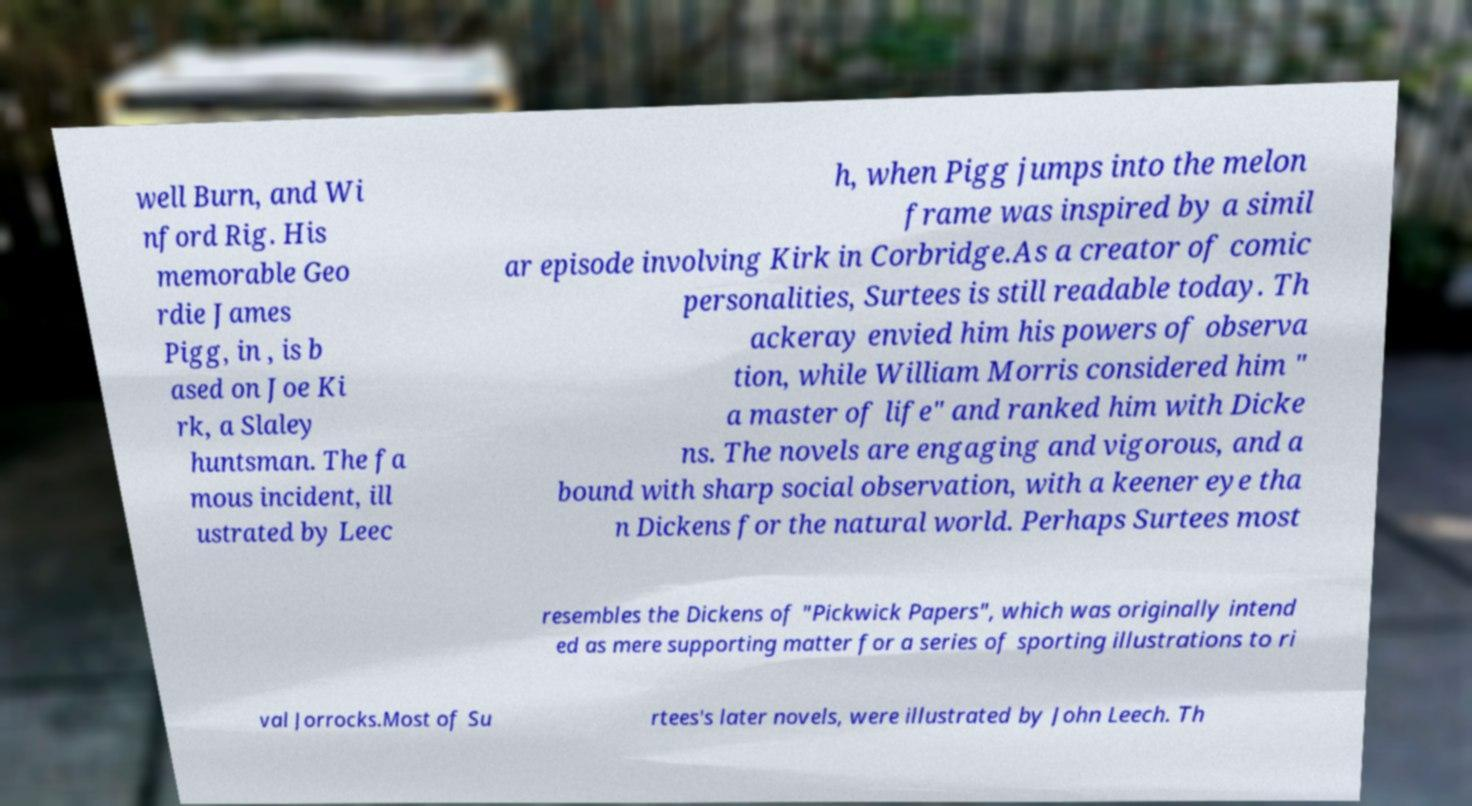For documentation purposes, I need the text within this image transcribed. Could you provide that? well Burn, and Wi nford Rig. His memorable Geo rdie James Pigg, in , is b ased on Joe Ki rk, a Slaley huntsman. The fa mous incident, ill ustrated by Leec h, when Pigg jumps into the melon frame was inspired by a simil ar episode involving Kirk in Corbridge.As a creator of comic personalities, Surtees is still readable today. Th ackeray envied him his powers of observa tion, while William Morris considered him " a master of life" and ranked him with Dicke ns. The novels are engaging and vigorous, and a bound with sharp social observation, with a keener eye tha n Dickens for the natural world. Perhaps Surtees most resembles the Dickens of "Pickwick Papers", which was originally intend ed as mere supporting matter for a series of sporting illustrations to ri val Jorrocks.Most of Su rtees's later novels, were illustrated by John Leech. Th 